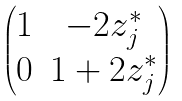Convert formula to latex. <formula><loc_0><loc_0><loc_500><loc_500>\begin{pmatrix} 1 & - 2 z _ { j } ^ { \ast } \\ 0 & 1 + 2 z _ { j } ^ { \ast } \end{pmatrix}</formula> 